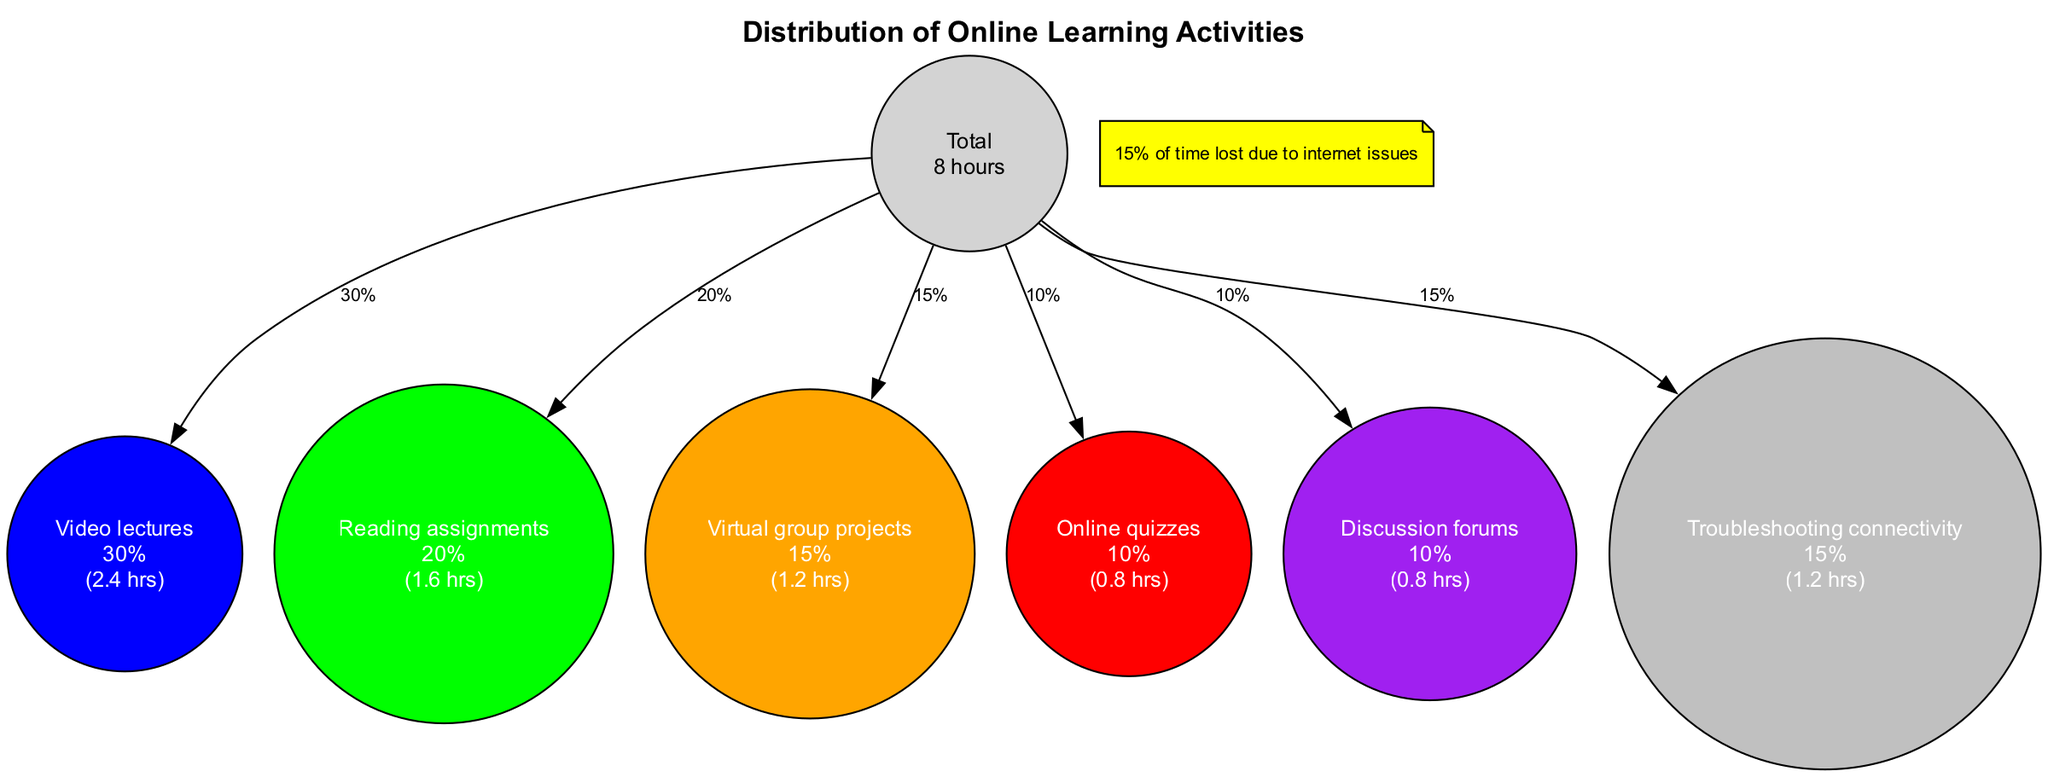What is the percentage of time spent on video lectures? The segment for video lectures states exactly "30%", which can be found in the percentage section of that activity.
Answer: 30% What is the total number of hours represented in the diagram? The center node displays "Total\n8 hours", indicating the total hours allocated for online learning activities in a typical school day.
Answer: 8 hours Which activity has the lowest percentage of time spent? By examining the percentage values for all activities, "Online quizzes" and "Discussion forums" both have the lowest percentage at "10%".
Answer: Online quizzes and Discussion forums How many activities have a percentage greater than 15%? Counting the activities, "Video lectures" (30%), "Reading assignments" (20%), and "Troubleshooting connectivity" (15%) are greater than 15%. Therefore, there are three activities that meet this condition.
Answer: 3 What color represents reading assignments in the diagram? The segment for reading assignments specifies the color "green", which is clearly indicated next to that activity in the chart.
Answer: Green What percentage of time is spent on troubleshooting connectivity? The segment for troubleshooting connectivity indicates a percentage of "15%", which can be found in the respective activity section of the diagram.
Answer: 15% How many total segments are there in the diagram? Counting all segments listed in the segments section, there are six distinct activities mentioned, confirming the number of segments.
Answer: 6 What does the note at the bottom of the diagram indicate? The note states "15% of time lost due to internet issues," conveying an important context regarding connectivity challenges faced during online learning.
Answer: 15% of time lost due to internet issues What is the combined percentage of time spent on virtual group projects and online quizzes? Adding the percentage for virtual group projects (15%) and online quizzes (10%) results in a total of 25%, which reflects the time spent combined on these activities.
Answer: 25% 